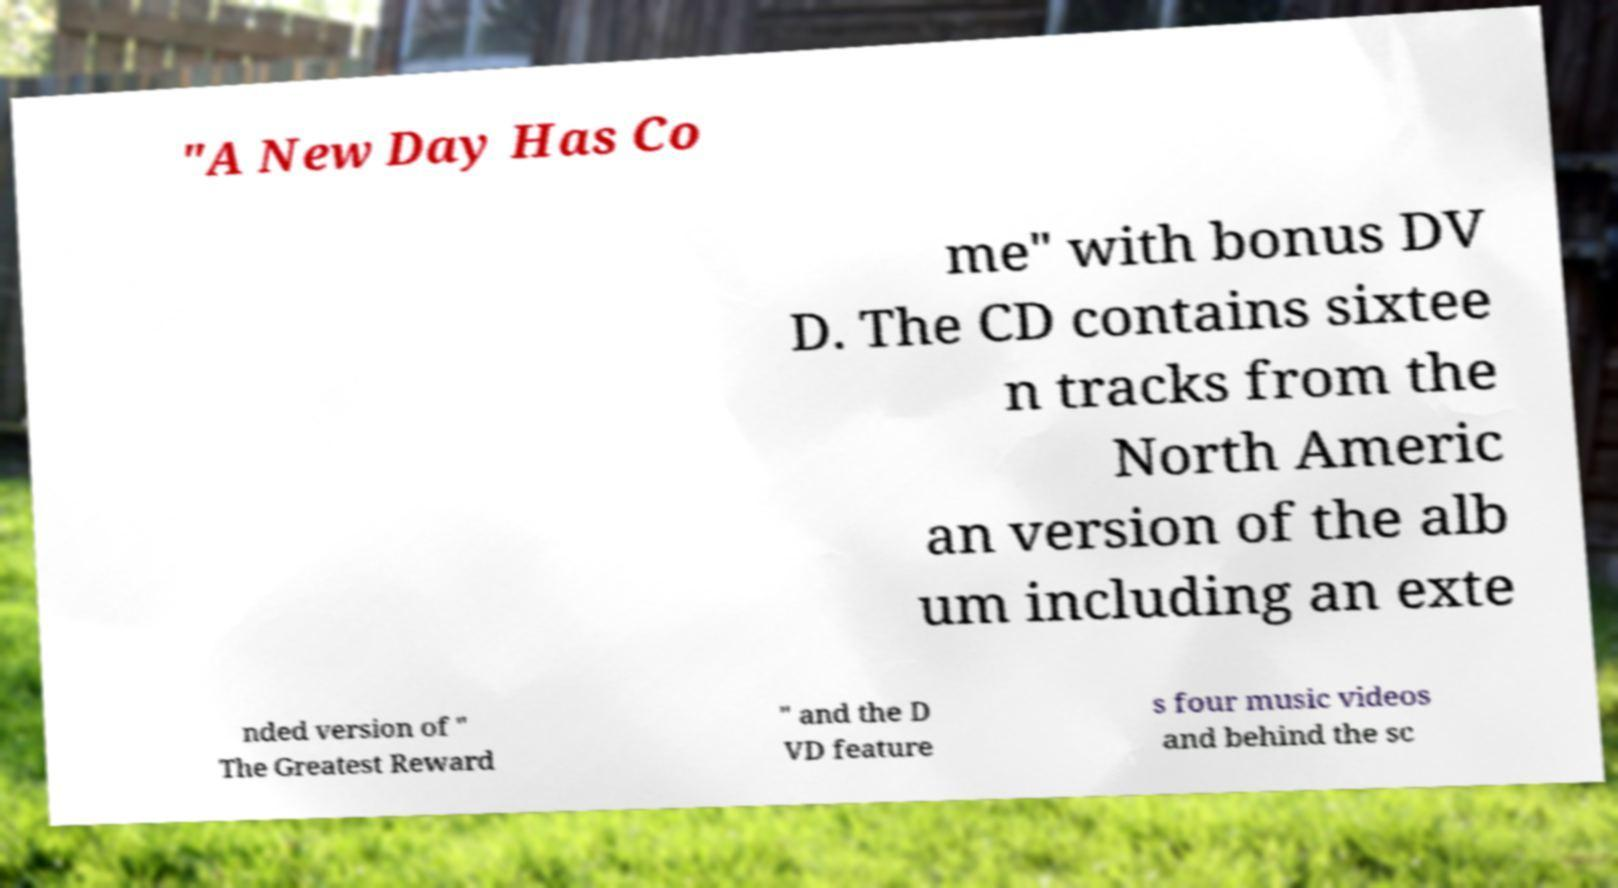Could you extract and type out the text from this image? "A New Day Has Co me" with bonus DV D. The CD contains sixtee n tracks from the North Americ an version of the alb um including an exte nded version of " The Greatest Reward " and the D VD feature s four music videos and behind the sc 